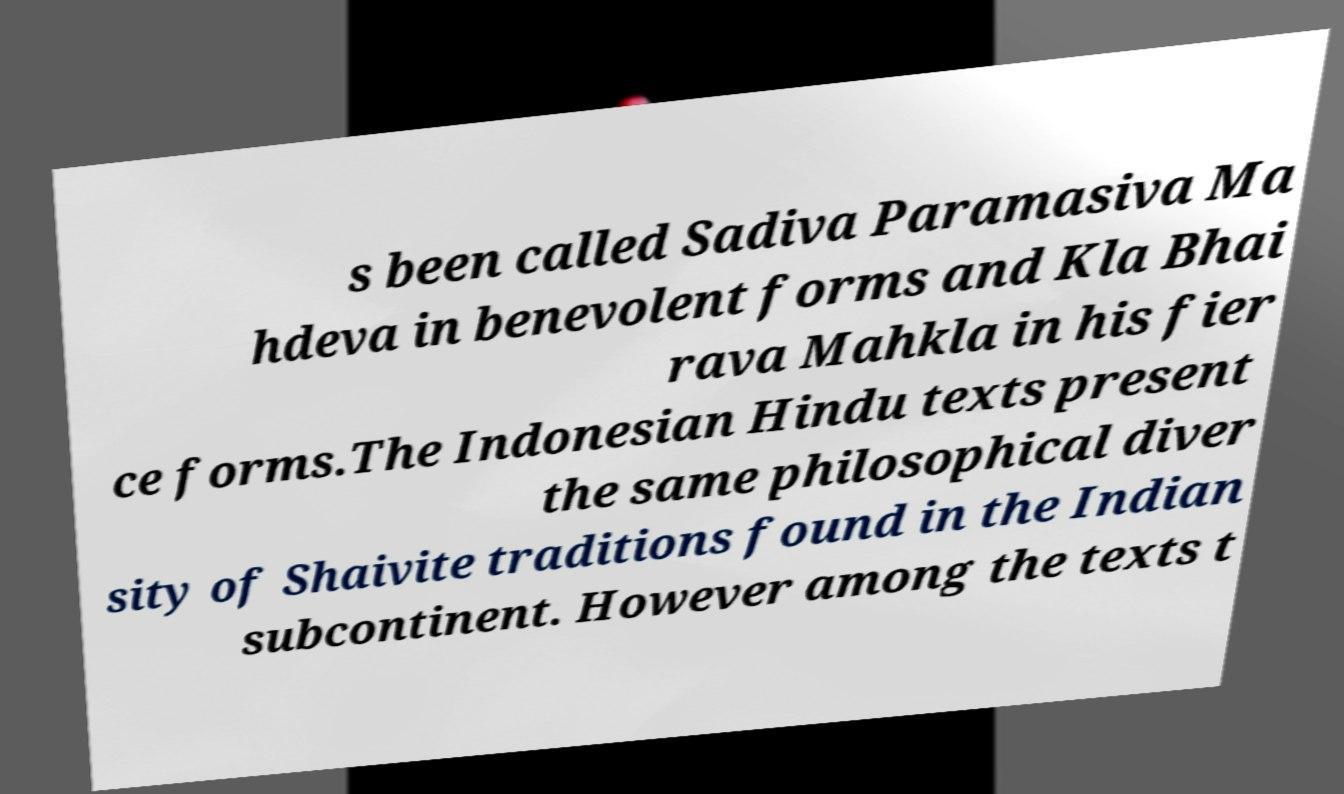Please identify and transcribe the text found in this image. s been called Sadiva Paramasiva Ma hdeva in benevolent forms and Kla Bhai rava Mahkla in his fier ce forms.The Indonesian Hindu texts present the same philosophical diver sity of Shaivite traditions found in the Indian subcontinent. However among the texts t 